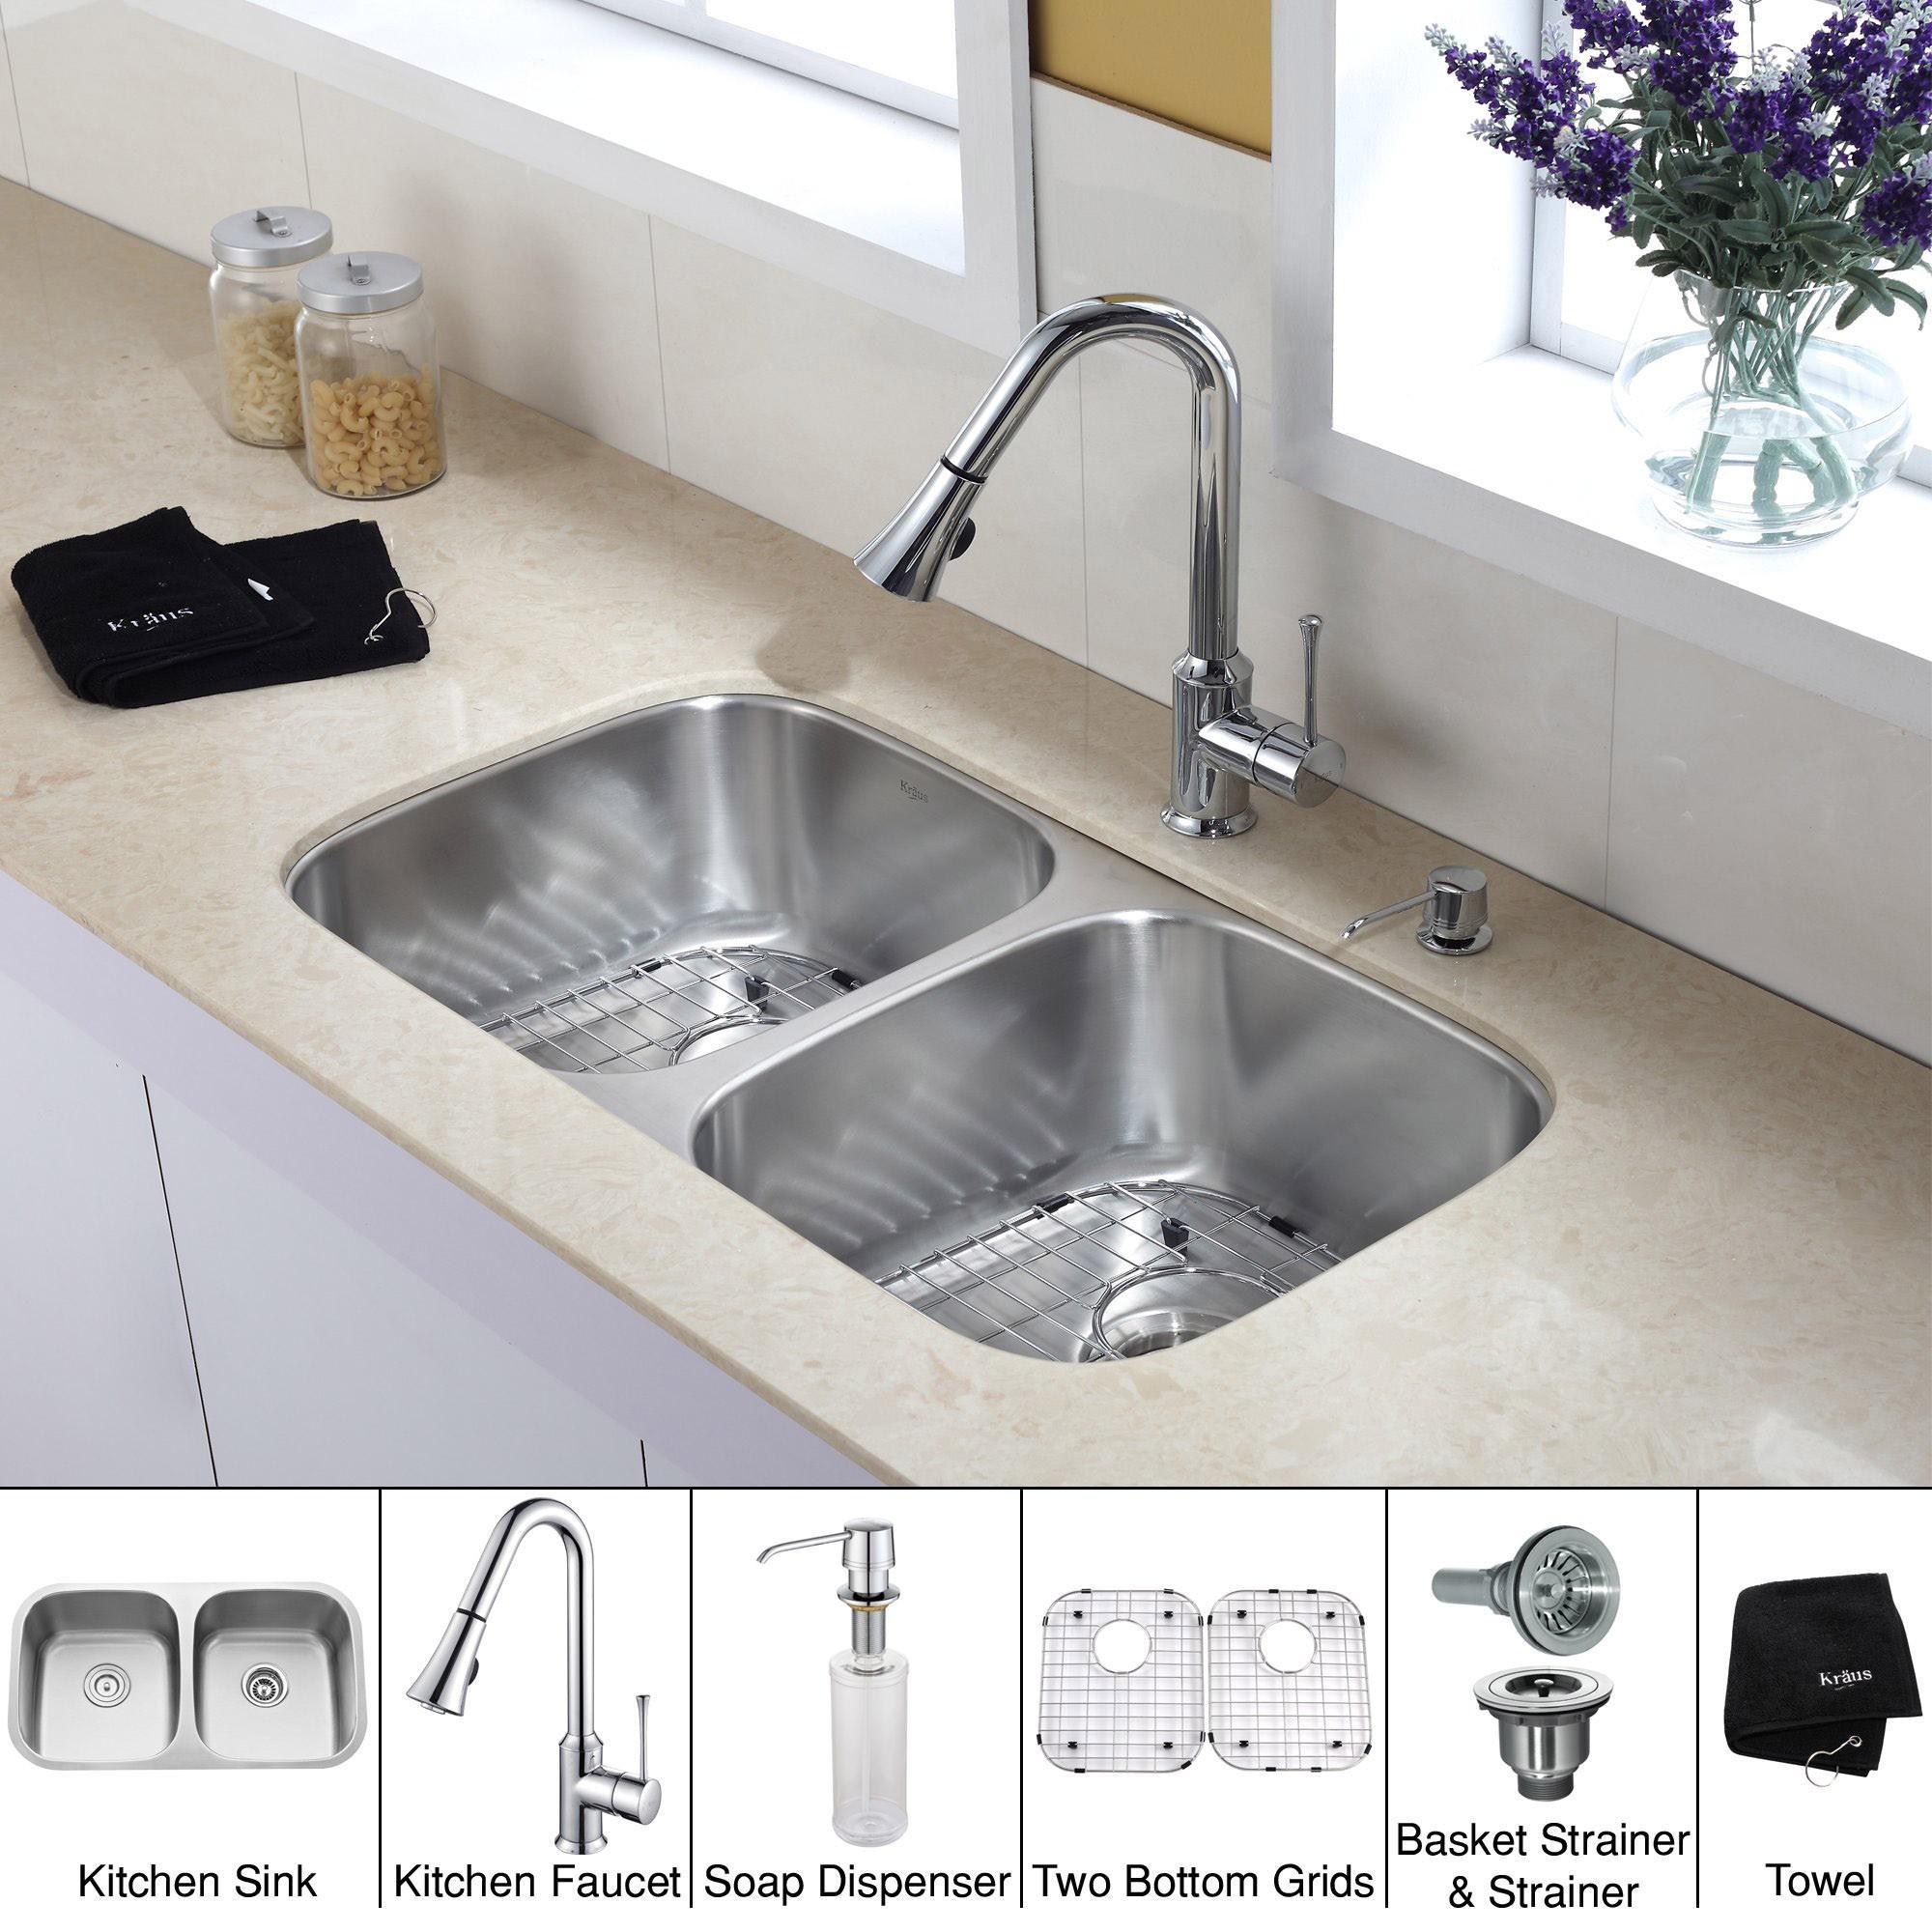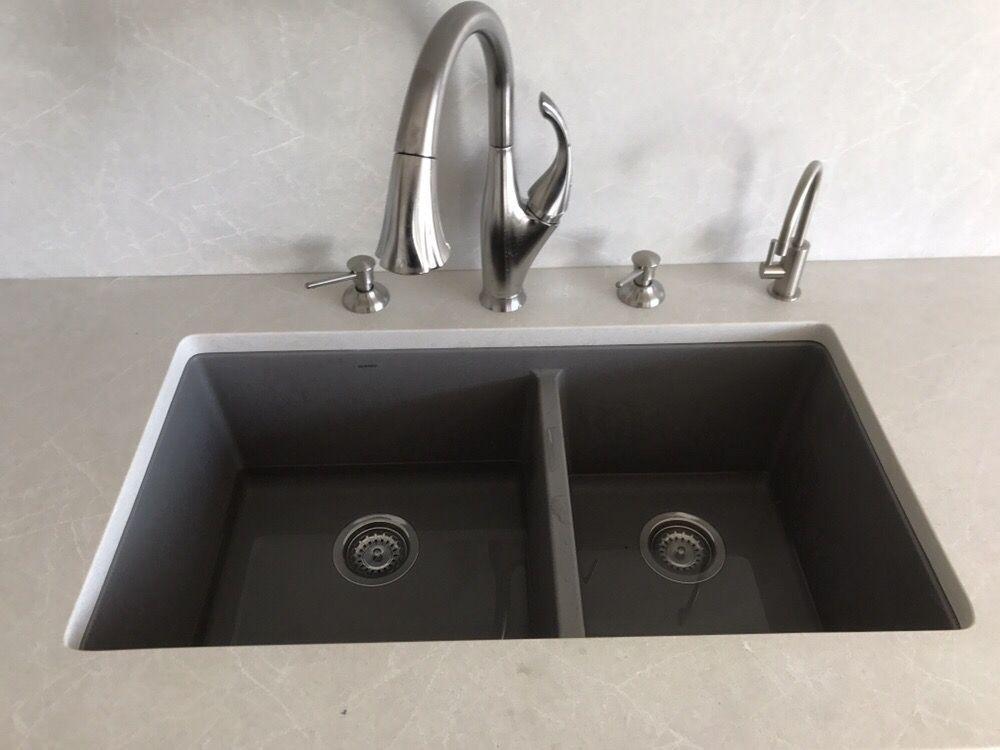The first image is the image on the left, the second image is the image on the right. Examine the images to the left and right. Is the description "The sink in the image on the right has a double basin." accurate? Answer yes or no. Yes. The first image is the image on the left, the second image is the image on the right. Considering the images on both sides, is "An image shows a single-basin steel sink with a wire rack insert, inset in a gray swirl marble counter." valid? Answer yes or no. No. 